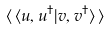Convert formula to latex. <formula><loc_0><loc_0><loc_500><loc_500>\langle \, \langle u , u ^ { \dagger } | { v } , { v } ^ { \dagger } \rangle \, \rangle</formula> 